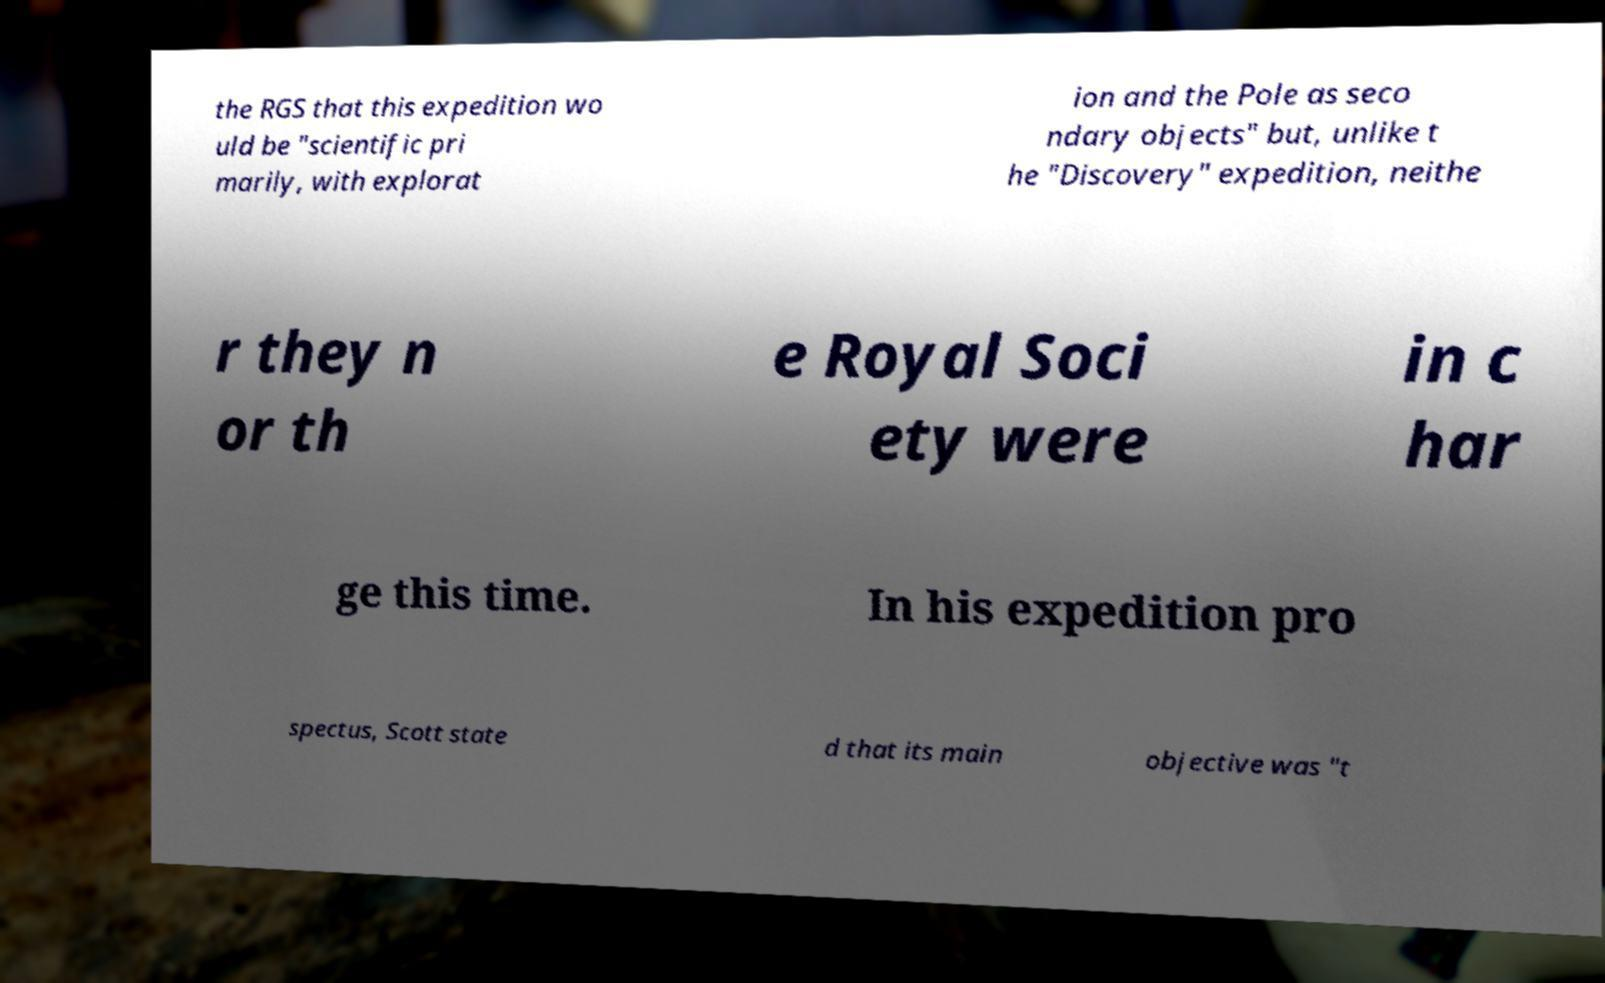I need the written content from this picture converted into text. Can you do that? the RGS that this expedition wo uld be "scientific pri marily, with explorat ion and the Pole as seco ndary objects" but, unlike t he "Discovery" expedition, neithe r they n or th e Royal Soci ety were in c har ge this time. In his expedition pro spectus, Scott state d that its main objective was "t 